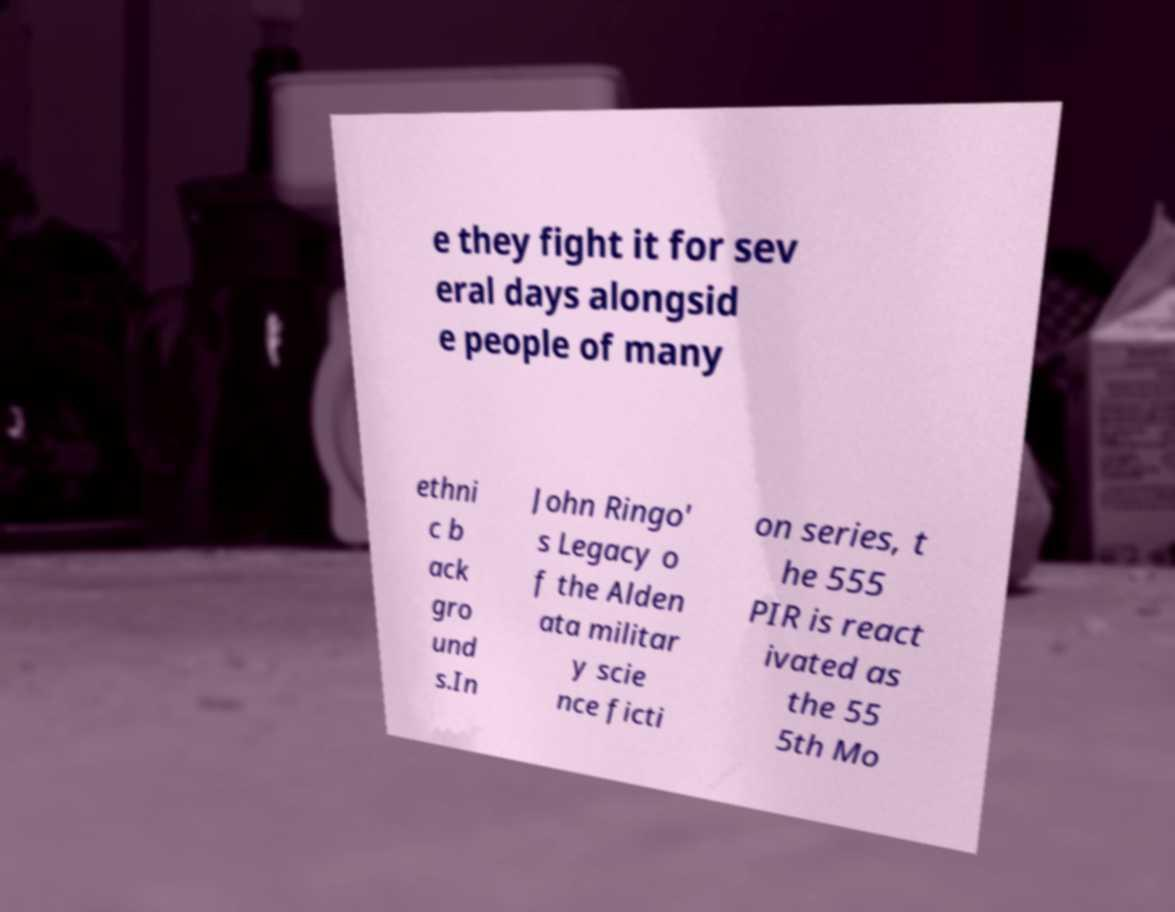What messages or text are displayed in this image? I need them in a readable, typed format. e they fight it for sev eral days alongsid e people of many ethni c b ack gro und s.In John Ringo' s Legacy o f the Alden ata militar y scie nce ficti on series, t he 555 PIR is react ivated as the 55 5th Mo 